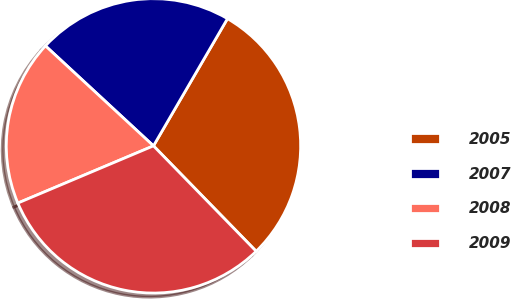Convert chart to OTSL. <chart><loc_0><loc_0><loc_500><loc_500><pie_chart><fcel>2005<fcel>2007<fcel>2008<fcel>2009<nl><fcel>29.32%<fcel>21.5%<fcel>18.24%<fcel>30.94%<nl></chart> 